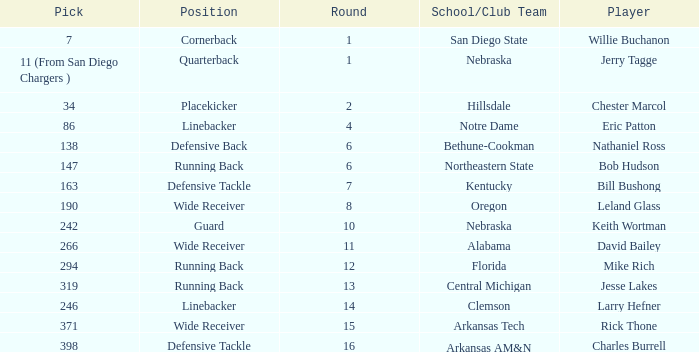Which round has a position that is cornerback? 1.0. 